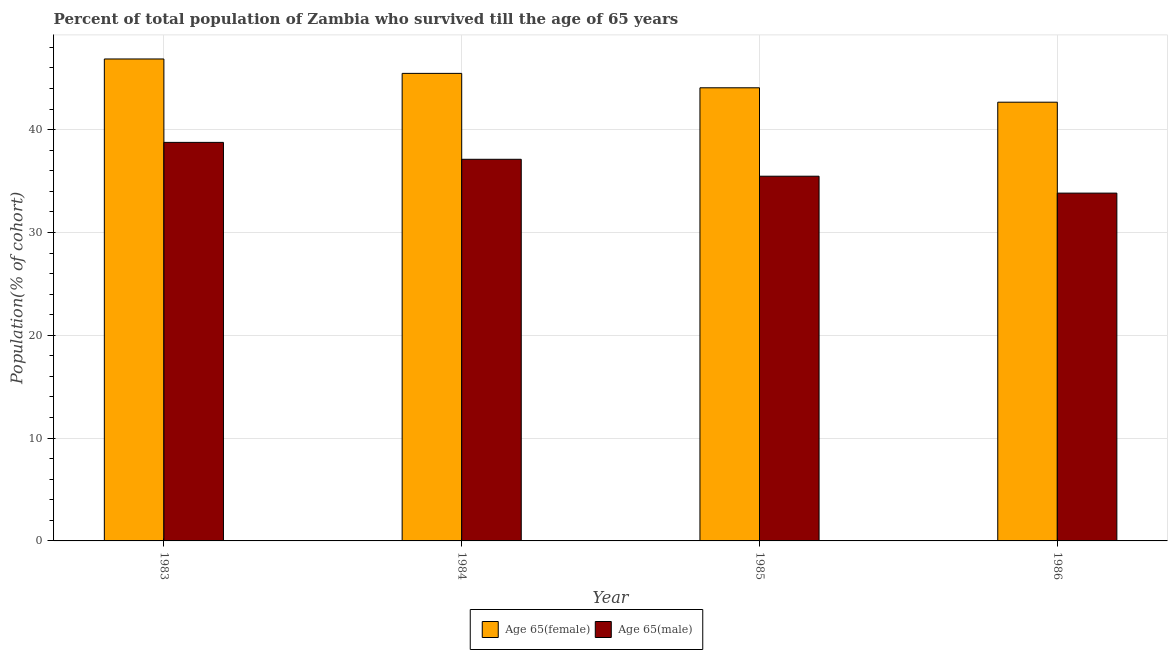How many different coloured bars are there?
Your answer should be compact. 2. Are the number of bars on each tick of the X-axis equal?
Offer a terse response. Yes. How many bars are there on the 3rd tick from the right?
Provide a short and direct response. 2. What is the label of the 1st group of bars from the left?
Provide a short and direct response. 1983. In how many cases, is the number of bars for a given year not equal to the number of legend labels?
Provide a short and direct response. 0. What is the percentage of female population who survived till age of 65 in 1984?
Your answer should be very brief. 45.48. Across all years, what is the maximum percentage of female population who survived till age of 65?
Offer a very short reply. 46.88. Across all years, what is the minimum percentage of female population who survived till age of 65?
Your answer should be compact. 42.67. In which year was the percentage of female population who survived till age of 65 maximum?
Keep it short and to the point. 1983. In which year was the percentage of female population who survived till age of 65 minimum?
Make the answer very short. 1986. What is the total percentage of female population who survived till age of 65 in the graph?
Offer a terse response. 179.1. What is the difference between the percentage of male population who survived till age of 65 in 1983 and that in 1985?
Make the answer very short. 3.29. What is the difference between the percentage of male population who survived till age of 65 in 1984 and the percentage of female population who survived till age of 65 in 1983?
Provide a succinct answer. -1.65. What is the average percentage of male population who survived till age of 65 per year?
Provide a short and direct response. 36.3. In how many years, is the percentage of female population who survived till age of 65 greater than 6 %?
Your answer should be compact. 4. What is the ratio of the percentage of male population who survived till age of 65 in 1983 to that in 1984?
Your response must be concise. 1.04. What is the difference between the highest and the second highest percentage of female population who survived till age of 65?
Keep it short and to the point. 1.4. What is the difference between the highest and the lowest percentage of female population who survived till age of 65?
Provide a succinct answer. 4.2. What does the 2nd bar from the left in 1985 represents?
Offer a very short reply. Age 65(male). What does the 2nd bar from the right in 1984 represents?
Provide a succinct answer. Age 65(female). How many bars are there?
Keep it short and to the point. 8. Are all the bars in the graph horizontal?
Provide a short and direct response. No. How many years are there in the graph?
Offer a very short reply. 4. What is the difference between two consecutive major ticks on the Y-axis?
Offer a terse response. 10. Are the values on the major ticks of Y-axis written in scientific E-notation?
Provide a succinct answer. No. Does the graph contain any zero values?
Provide a short and direct response. No. How many legend labels are there?
Provide a succinct answer. 2. How are the legend labels stacked?
Keep it short and to the point. Horizontal. What is the title of the graph?
Offer a very short reply. Percent of total population of Zambia who survived till the age of 65 years. What is the label or title of the X-axis?
Provide a succinct answer. Year. What is the label or title of the Y-axis?
Your answer should be compact. Population(% of cohort). What is the Population(% of cohort) of Age 65(female) in 1983?
Offer a very short reply. 46.88. What is the Population(% of cohort) of Age 65(male) in 1983?
Provide a short and direct response. 38.76. What is the Population(% of cohort) in Age 65(female) in 1984?
Provide a succinct answer. 45.48. What is the Population(% of cohort) of Age 65(male) in 1984?
Keep it short and to the point. 37.12. What is the Population(% of cohort) in Age 65(female) in 1985?
Your response must be concise. 44.07. What is the Population(% of cohort) of Age 65(male) in 1985?
Ensure brevity in your answer.  35.47. What is the Population(% of cohort) in Age 65(female) in 1986?
Your response must be concise. 42.67. What is the Population(% of cohort) of Age 65(male) in 1986?
Make the answer very short. 33.83. Across all years, what is the maximum Population(% of cohort) of Age 65(female)?
Ensure brevity in your answer.  46.88. Across all years, what is the maximum Population(% of cohort) in Age 65(male)?
Your answer should be compact. 38.76. Across all years, what is the minimum Population(% of cohort) in Age 65(female)?
Give a very brief answer. 42.67. Across all years, what is the minimum Population(% of cohort) in Age 65(male)?
Offer a very short reply. 33.83. What is the total Population(% of cohort) of Age 65(female) in the graph?
Provide a short and direct response. 179.1. What is the total Population(% of cohort) in Age 65(male) in the graph?
Ensure brevity in your answer.  145.18. What is the difference between the Population(% of cohort) in Age 65(female) in 1983 and that in 1984?
Ensure brevity in your answer.  1.4. What is the difference between the Population(% of cohort) in Age 65(male) in 1983 and that in 1984?
Your answer should be compact. 1.65. What is the difference between the Population(% of cohort) of Age 65(female) in 1983 and that in 1985?
Offer a terse response. 2.8. What is the difference between the Population(% of cohort) in Age 65(male) in 1983 and that in 1985?
Your answer should be compact. 3.29. What is the difference between the Population(% of cohort) in Age 65(female) in 1983 and that in 1986?
Give a very brief answer. 4.2. What is the difference between the Population(% of cohort) of Age 65(male) in 1983 and that in 1986?
Your answer should be very brief. 4.94. What is the difference between the Population(% of cohort) of Age 65(female) in 1984 and that in 1985?
Provide a short and direct response. 1.4. What is the difference between the Population(% of cohort) in Age 65(male) in 1984 and that in 1985?
Give a very brief answer. 1.65. What is the difference between the Population(% of cohort) in Age 65(female) in 1984 and that in 1986?
Offer a very short reply. 2.8. What is the difference between the Population(% of cohort) of Age 65(male) in 1984 and that in 1986?
Offer a terse response. 3.29. What is the difference between the Population(% of cohort) in Age 65(female) in 1985 and that in 1986?
Your answer should be very brief. 1.4. What is the difference between the Population(% of cohort) of Age 65(male) in 1985 and that in 1986?
Ensure brevity in your answer.  1.65. What is the difference between the Population(% of cohort) in Age 65(female) in 1983 and the Population(% of cohort) in Age 65(male) in 1984?
Keep it short and to the point. 9.76. What is the difference between the Population(% of cohort) of Age 65(female) in 1983 and the Population(% of cohort) of Age 65(male) in 1985?
Make the answer very short. 11.4. What is the difference between the Population(% of cohort) of Age 65(female) in 1983 and the Population(% of cohort) of Age 65(male) in 1986?
Your answer should be very brief. 13.05. What is the difference between the Population(% of cohort) in Age 65(female) in 1984 and the Population(% of cohort) in Age 65(male) in 1985?
Give a very brief answer. 10. What is the difference between the Population(% of cohort) in Age 65(female) in 1984 and the Population(% of cohort) in Age 65(male) in 1986?
Provide a succinct answer. 11.65. What is the difference between the Population(% of cohort) in Age 65(female) in 1985 and the Population(% of cohort) in Age 65(male) in 1986?
Make the answer very short. 10.25. What is the average Population(% of cohort) of Age 65(female) per year?
Provide a short and direct response. 44.77. What is the average Population(% of cohort) of Age 65(male) per year?
Provide a succinct answer. 36.3. In the year 1983, what is the difference between the Population(% of cohort) of Age 65(female) and Population(% of cohort) of Age 65(male)?
Keep it short and to the point. 8.11. In the year 1984, what is the difference between the Population(% of cohort) of Age 65(female) and Population(% of cohort) of Age 65(male)?
Make the answer very short. 8.36. In the year 1985, what is the difference between the Population(% of cohort) in Age 65(female) and Population(% of cohort) in Age 65(male)?
Provide a succinct answer. 8.6. In the year 1986, what is the difference between the Population(% of cohort) in Age 65(female) and Population(% of cohort) in Age 65(male)?
Offer a terse response. 8.84. What is the ratio of the Population(% of cohort) in Age 65(female) in 1983 to that in 1984?
Ensure brevity in your answer.  1.03. What is the ratio of the Population(% of cohort) of Age 65(male) in 1983 to that in 1984?
Keep it short and to the point. 1.04. What is the ratio of the Population(% of cohort) of Age 65(female) in 1983 to that in 1985?
Ensure brevity in your answer.  1.06. What is the ratio of the Population(% of cohort) in Age 65(male) in 1983 to that in 1985?
Make the answer very short. 1.09. What is the ratio of the Population(% of cohort) in Age 65(female) in 1983 to that in 1986?
Give a very brief answer. 1.1. What is the ratio of the Population(% of cohort) of Age 65(male) in 1983 to that in 1986?
Ensure brevity in your answer.  1.15. What is the ratio of the Population(% of cohort) in Age 65(female) in 1984 to that in 1985?
Offer a terse response. 1.03. What is the ratio of the Population(% of cohort) in Age 65(male) in 1984 to that in 1985?
Make the answer very short. 1.05. What is the ratio of the Population(% of cohort) of Age 65(female) in 1984 to that in 1986?
Make the answer very short. 1.07. What is the ratio of the Population(% of cohort) of Age 65(male) in 1984 to that in 1986?
Offer a very short reply. 1.1. What is the ratio of the Population(% of cohort) in Age 65(female) in 1985 to that in 1986?
Your answer should be very brief. 1.03. What is the ratio of the Population(% of cohort) of Age 65(male) in 1985 to that in 1986?
Your answer should be compact. 1.05. What is the difference between the highest and the second highest Population(% of cohort) of Age 65(female)?
Offer a very short reply. 1.4. What is the difference between the highest and the second highest Population(% of cohort) of Age 65(male)?
Provide a succinct answer. 1.65. What is the difference between the highest and the lowest Population(% of cohort) in Age 65(female)?
Give a very brief answer. 4.2. What is the difference between the highest and the lowest Population(% of cohort) of Age 65(male)?
Your answer should be very brief. 4.94. 